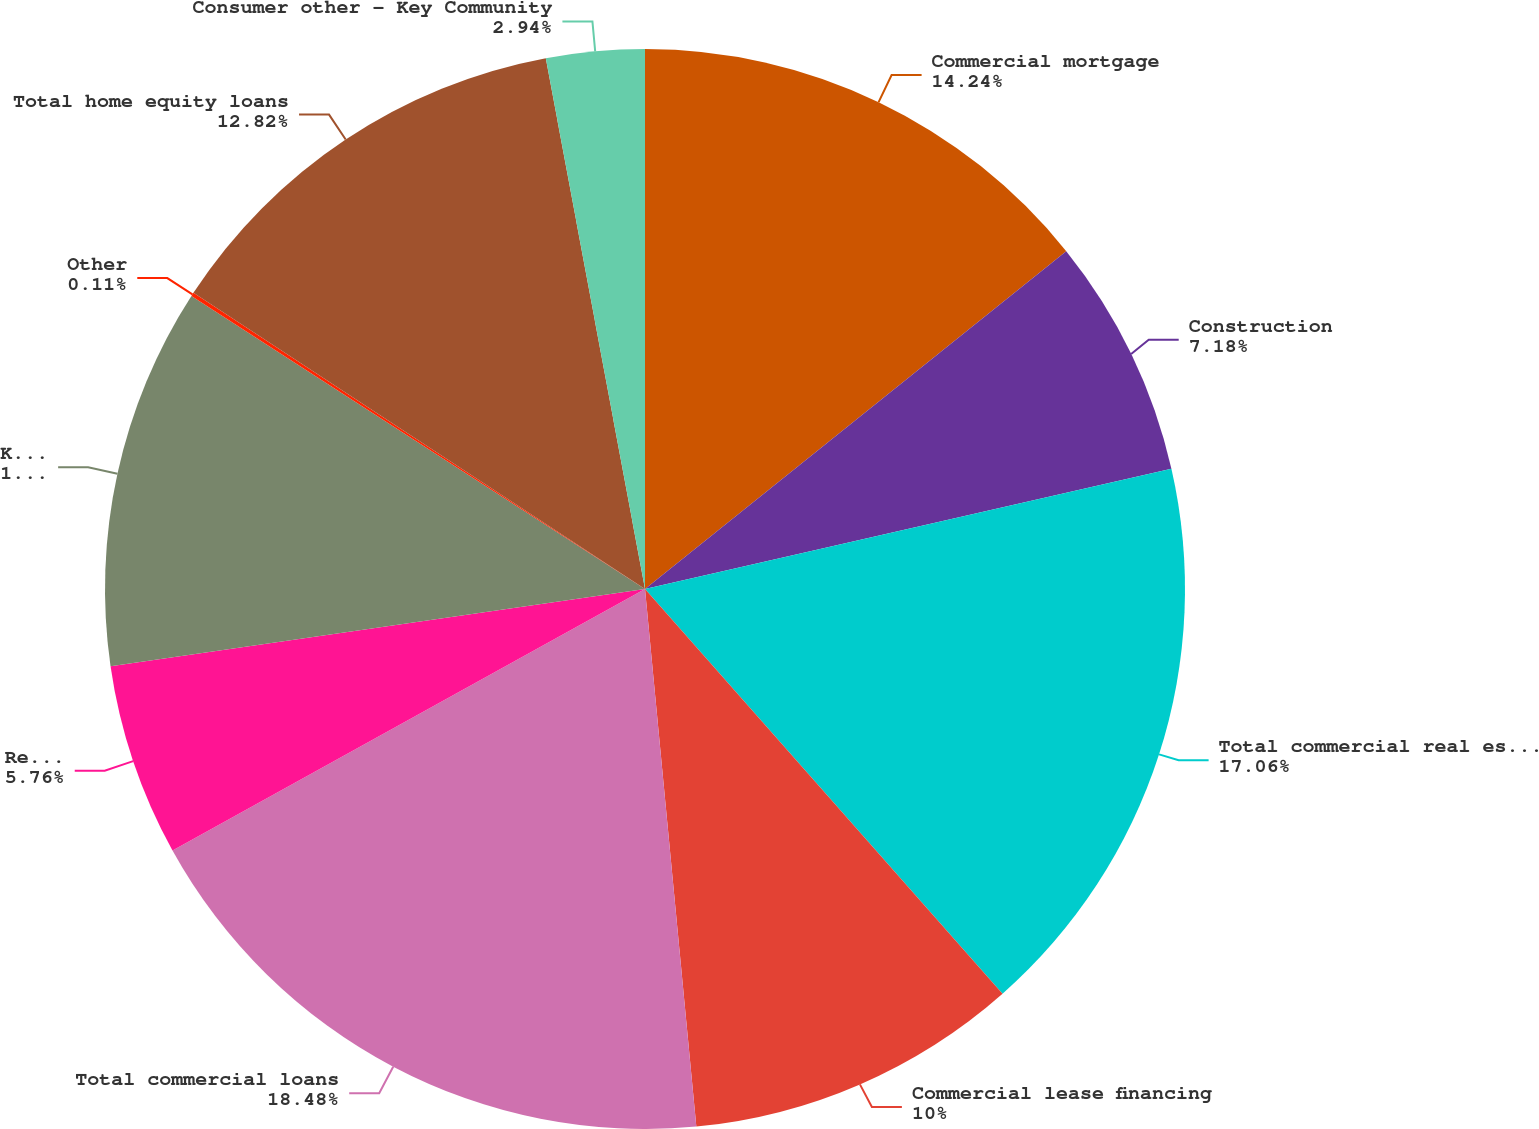Convert chart to OTSL. <chart><loc_0><loc_0><loc_500><loc_500><pie_chart><fcel>Commercial mortgage<fcel>Construction<fcel>Total commercial real estate<fcel>Commercial lease financing<fcel>Total commercial loans<fcel>Real estate - residential<fcel>Key Community Bank<fcel>Other<fcel>Total home equity loans<fcel>Consumer other - Key Community<nl><fcel>14.24%<fcel>7.18%<fcel>17.06%<fcel>10.0%<fcel>18.47%<fcel>5.76%<fcel>11.41%<fcel>0.11%<fcel>12.82%<fcel>2.94%<nl></chart> 